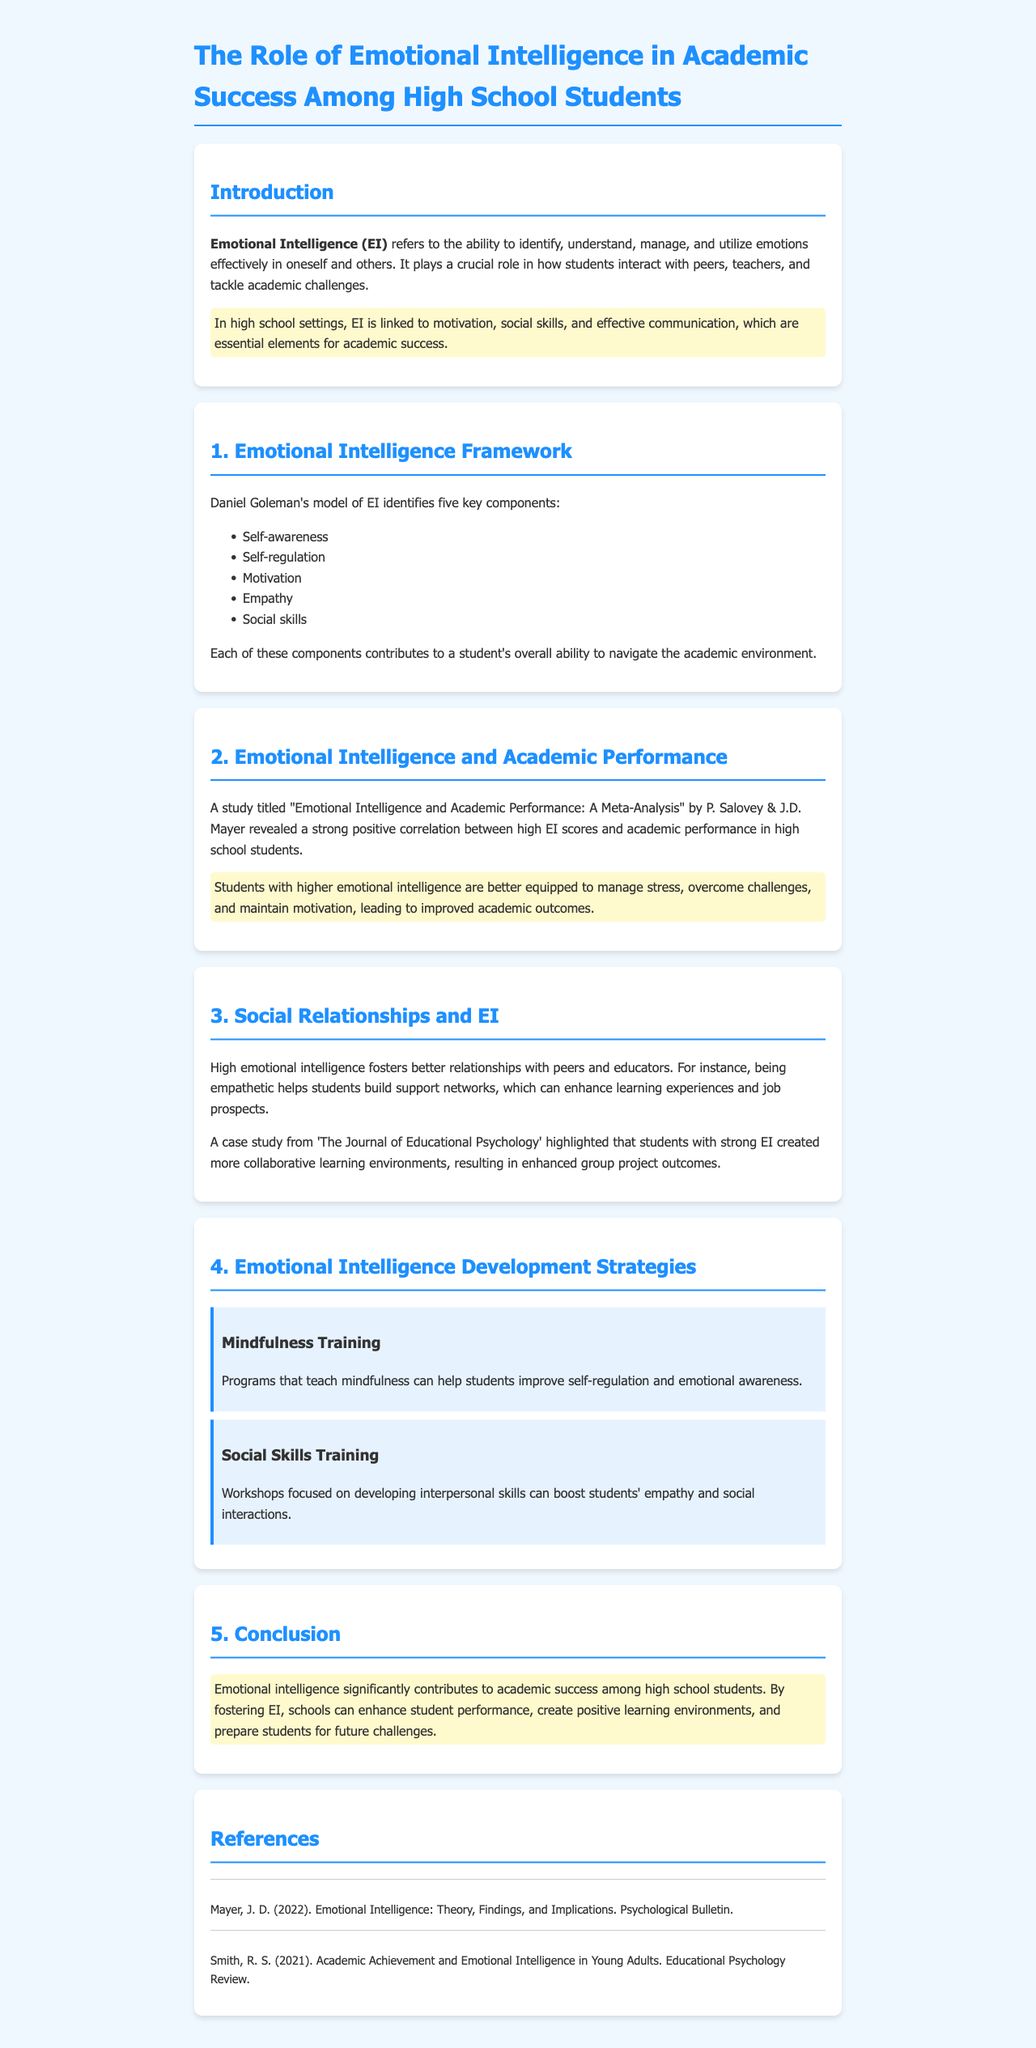What does EI stand for? EI is defined in the document as Emotional Intelligence.
Answer: Emotional Intelligence Who proposed the emotional intelligence model discussed? The document mentions Daniel Goleman as the model's proposer.
Answer: Daniel Goleman What is one way Emotional Intelligence contributes to academic success? The document states that higher emotional intelligence helps manage stress, leading to improved academic outcomes.
Answer: Manage stress How many key components does Goleman's model of EI identify? The document lists five key components in Goleman's model of EI.
Answer: Five What strategy is mentioned for improving self-regulation? The document discusses mindfulness training as a method for improving self-regulation.
Answer: Mindfulness Training According to the document, what is a benefit of strong emotional intelligence in relationships? The document highlights that strong EI fosters better relationships with peers and educators.
Answer: Better relationships What kind of training is mentioned to boost students' empathy? The document refers to social skills training as a way to increase empathy.
Answer: Social Skills Training What is the main conclusion regarding Emotional Intelligence in the report? The document concludes that Emotional Intelligence significantly contributes to academic success among high school students.
Answer: Significant contribution Which journal is cited for a case study on collaborative learning environments? The document mentions 'The Journal of Educational Psychology' for the case study referenced.
Answer: The Journal of Educational Psychology 